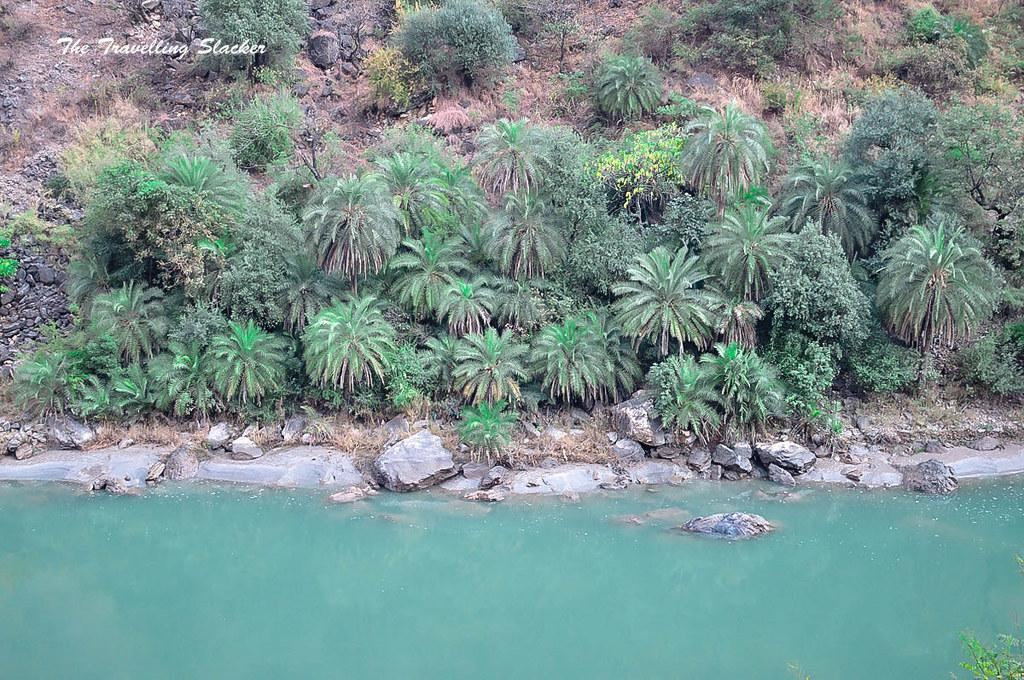What type of natural elements can be seen in the image? There are trees, rocks, and stones in the image. What is visible at the bottom of the image? There is water visible at the bottom of the image. Where is the text located in the image? The text is in the top left corner of the image. What type of parent is depicted in the image? There is no parent depicted in the image; it features natural elements such as trees, rocks, stones, water, and text. What is the aftermath of the event shown in the image? There is no event depicted in the image, so it is not possible to determine the aftermath. 